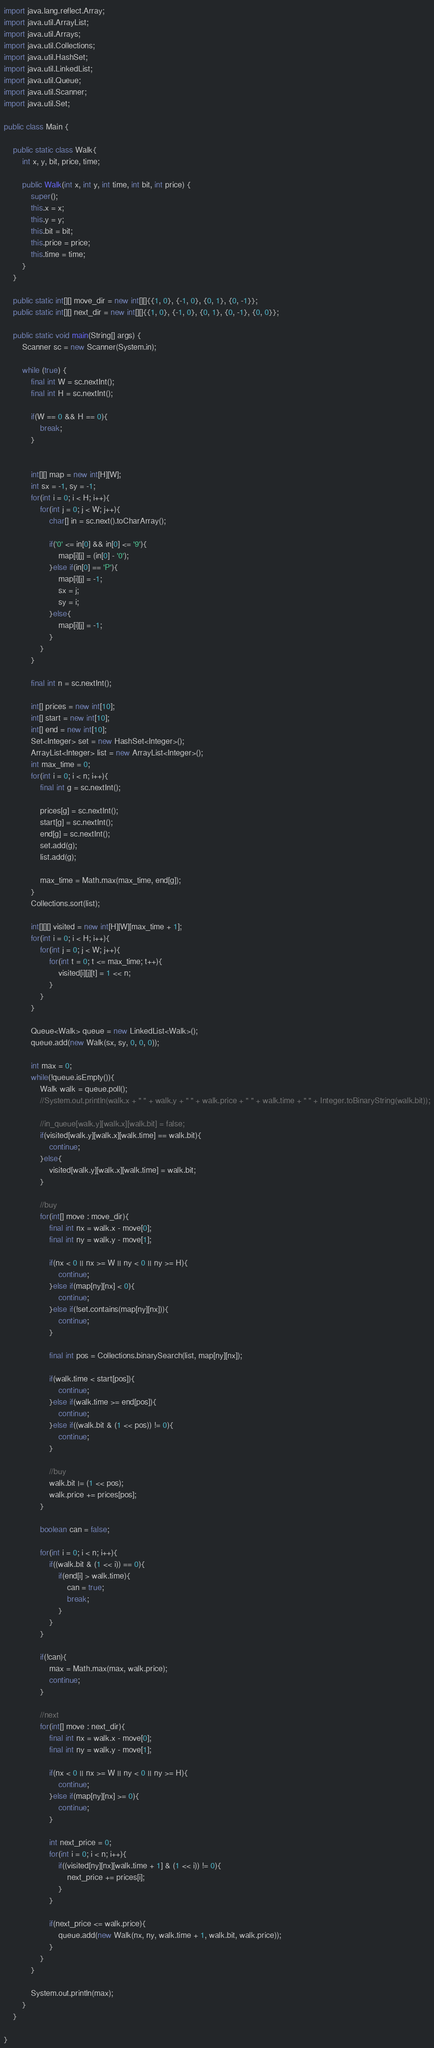Convert code to text. <code><loc_0><loc_0><loc_500><loc_500><_Java_>import java.lang.reflect.Array;
import java.util.ArrayList;
import java.util.Arrays;
import java.util.Collections;
import java.util.HashSet;
import java.util.LinkedList;
import java.util.Queue;
import java.util.Scanner;
import java.util.Set;

public class Main {
	
	public static class Walk{
		int x, y, bit, price, time;

		public Walk(int x, int y, int time, int bit, int price) {
			super();
			this.x = x;
			this.y = y;
			this.bit = bit;
			this.price = price;
			this.time = time;
		}
	}
	
	public static int[][] move_dir = new int[][]{{1, 0}, {-1, 0}, {0, 1}, {0, -1}};
	public static int[][] next_dir = new int[][]{{1, 0}, {-1, 0}, {0, 1}, {0, -1}, {0, 0}};
	
	public static void main(String[] args) {
		Scanner sc = new Scanner(System.in);
		
		while (true) {
			final int W = sc.nextInt();
			final int H = sc.nextInt();
			
			if(W == 0 && H == 0){
				break;
			}
			
			
			int[][] map = new int[H][W];
			int sx = -1, sy = -1;
			for(int i = 0; i < H; i++){
				for(int j = 0; j < W; j++){
					char[] in = sc.next().toCharArray();
					
					if('0' <= in[0] && in[0] <= '9'){
						map[i][j] = (in[0] - '0');
					}else if(in[0] == 'P'){
						map[i][j] = -1;
						sx = j;
						sy = i;
					}else{
						map[i][j] = -1;
					}
				}
			}
			
			final int n = sc.nextInt();
			
			int[] prices = new int[10];
			int[] start = new int[10];
			int[] end = new int[10];
			Set<Integer> set = new HashSet<Integer>();
			ArrayList<Integer> list = new ArrayList<Integer>();
			int max_time = 0;
			for(int i = 0; i < n; i++){
				final int g = sc.nextInt();
				
				prices[g] = sc.nextInt();
				start[g] = sc.nextInt();
				end[g] = sc.nextInt();
				set.add(g);
				list.add(g);
				
				max_time = Math.max(max_time, end[g]);
			}
			Collections.sort(list);
			
			int[][][] visited = new int[H][W][max_time + 1];
			for(int i = 0; i < H; i++){
				for(int j = 0; j < W; j++){
					for(int t = 0; t <= max_time; t++){
						visited[i][j][t] = 1 << n;
					}
				}
			}
			
			Queue<Walk> queue = new LinkedList<Walk>();
			queue.add(new Walk(sx, sy, 0, 0, 0));
			
			int max = 0;
			while(!queue.isEmpty()){
				Walk walk = queue.poll();
				//System.out.println(walk.x + " " + walk.y + " " + walk.price + " " + walk.time + " " + Integer.toBinaryString(walk.bit));
				
				//in_queue[walk.y][walk.x][walk.bit] = false;
				if(visited[walk.y][walk.x][walk.time] == walk.bit){
					continue;
				}else{
					visited[walk.y][walk.x][walk.time] = walk.bit;
				}
				
				//buy
				for(int[] move : move_dir){
					final int nx = walk.x - move[0];
					final int ny = walk.y - move[1];
						
					if(nx < 0 || nx >= W || ny < 0 || ny >= H){
						continue;
					}else if(map[ny][nx] < 0){
						continue;
					}else if(!set.contains(map[ny][nx])){
						continue;
					}
					
					final int pos = Collections.binarySearch(list, map[ny][nx]);
					
					if(walk.time < start[pos]){
						continue;
					}else if(walk.time >= end[pos]){
						continue;
					}else if((walk.bit & (1 << pos)) != 0){
						continue;
					}
					
					//buy
					walk.bit |= (1 << pos);
					walk.price += prices[pos];
				}
				
				boolean can = false;
					
				for(int i = 0; i < n; i++){
					if((walk.bit & (1 << i)) == 0){
						if(end[i] > walk.time){
							can = true;
							break;
						}
					}
				}
					
				if(!can){
					max = Math.max(max, walk.price);
					continue;
				}
				
				//next
				for(int[] move : next_dir){
					final int nx = walk.x - move[0];
					final int ny = walk.y - move[1];
					
					if(nx < 0 || nx >= W || ny < 0 || ny >= H){
						continue;
					}else if(map[ny][nx] >= 0){
						continue;
					}
					
					int next_price = 0;
					for(int i = 0; i < n; i++){
						if((visited[ny][nx][walk.time + 1] & (1 << i)) != 0){
							next_price += prices[i];
						}
					}
					
					if(next_price <= walk.price){
						queue.add(new Walk(nx, ny, walk.time + 1, walk.bit, walk.price));
					}
				}
			}
			
			System.out.println(max);
		}
	}

}</code> 